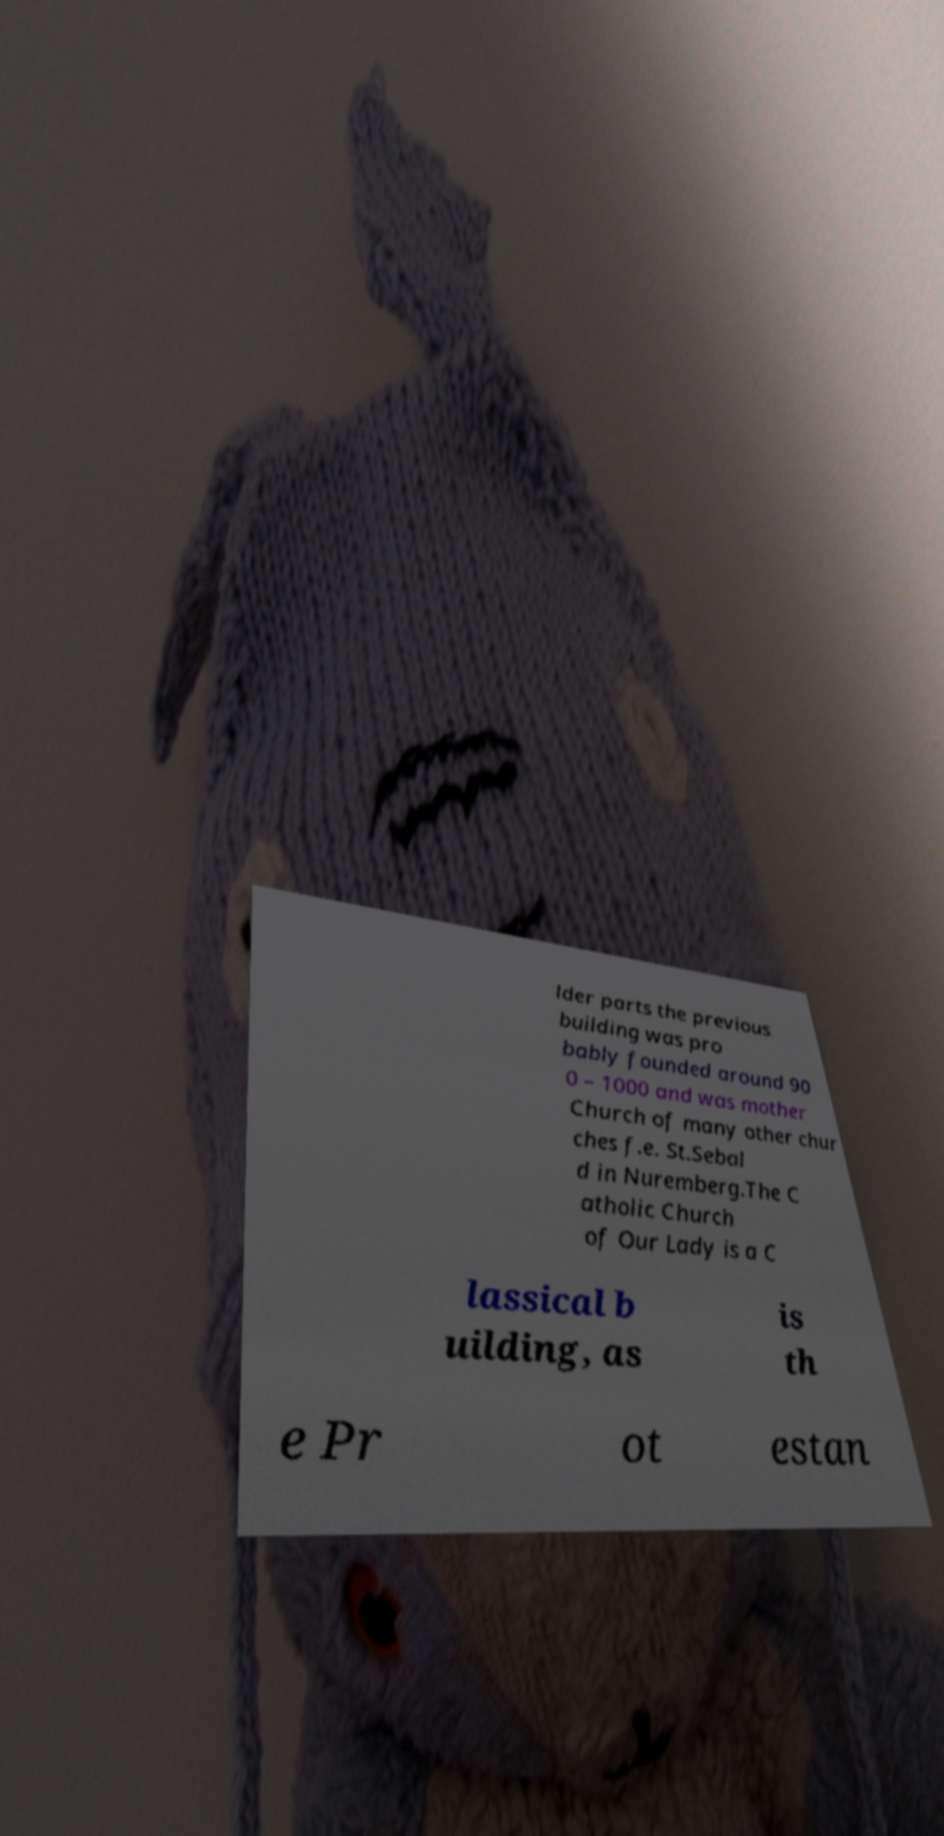Can you read and provide the text displayed in the image?This photo seems to have some interesting text. Can you extract and type it out for me? lder parts the previous building was pro bably founded around 90 0 – 1000 and was mother Church of many other chur ches f.e. St.Sebal d in Nuremberg.The C atholic Church of Our Lady is a C lassical b uilding, as is th e Pr ot estan 